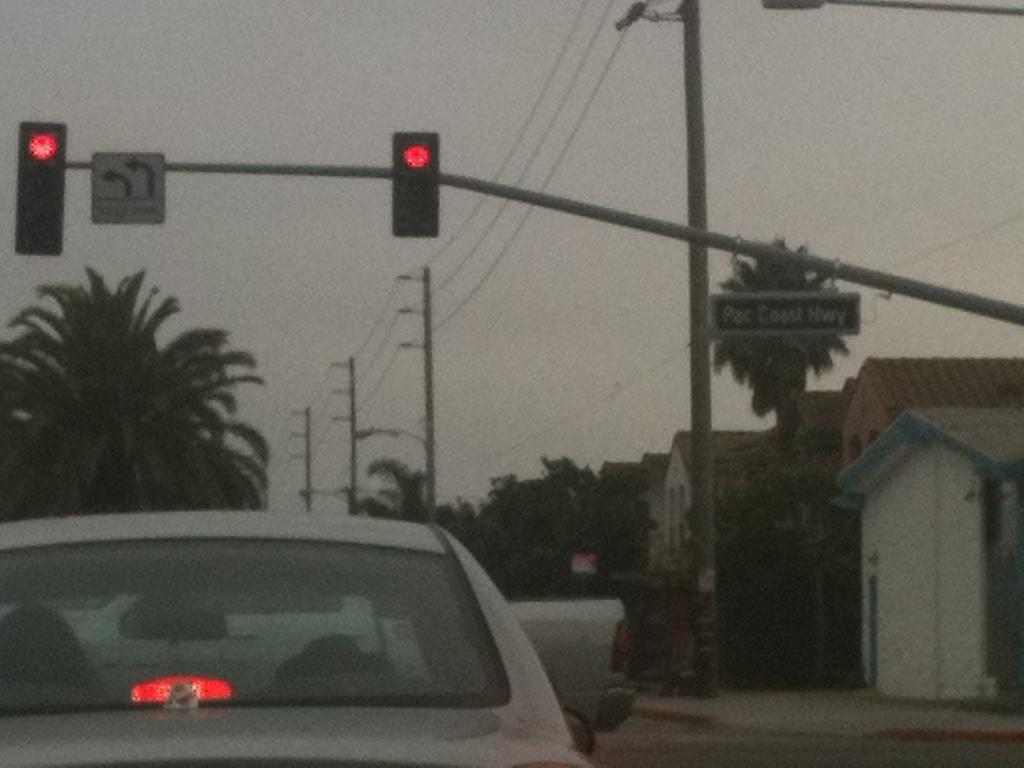<image>
Give a short and clear explanation of the subsequent image. A blurry picture shows a Pac Coast Hwy street sign. 